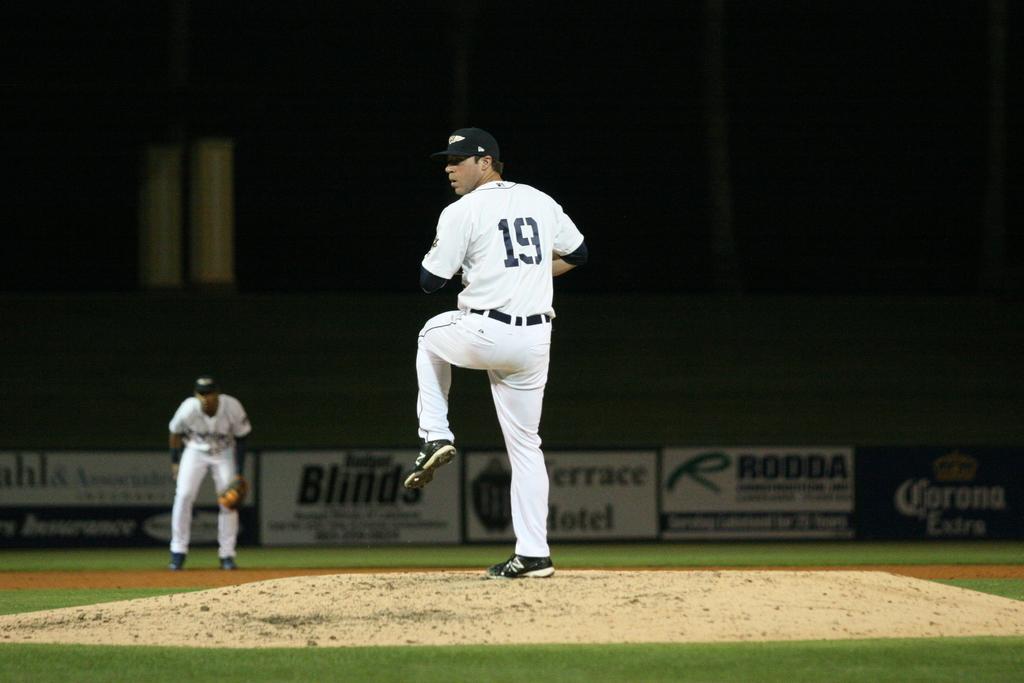What alcohol brand is advertised in the background?
Ensure brevity in your answer.  Corona extra. 